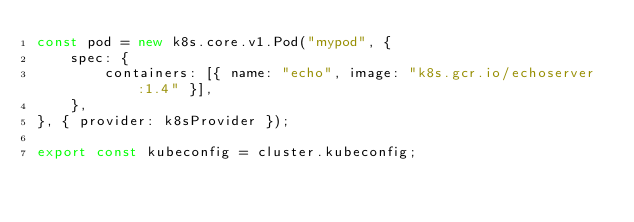<code> <loc_0><loc_0><loc_500><loc_500><_TypeScript_>const pod = new k8s.core.v1.Pod("mypod", {
    spec: {
        containers: [{ name: "echo", image: "k8s.gcr.io/echoserver:1.4" }],
    },
}, { provider: k8sProvider });

export const kubeconfig = cluster.kubeconfig;
</code> 